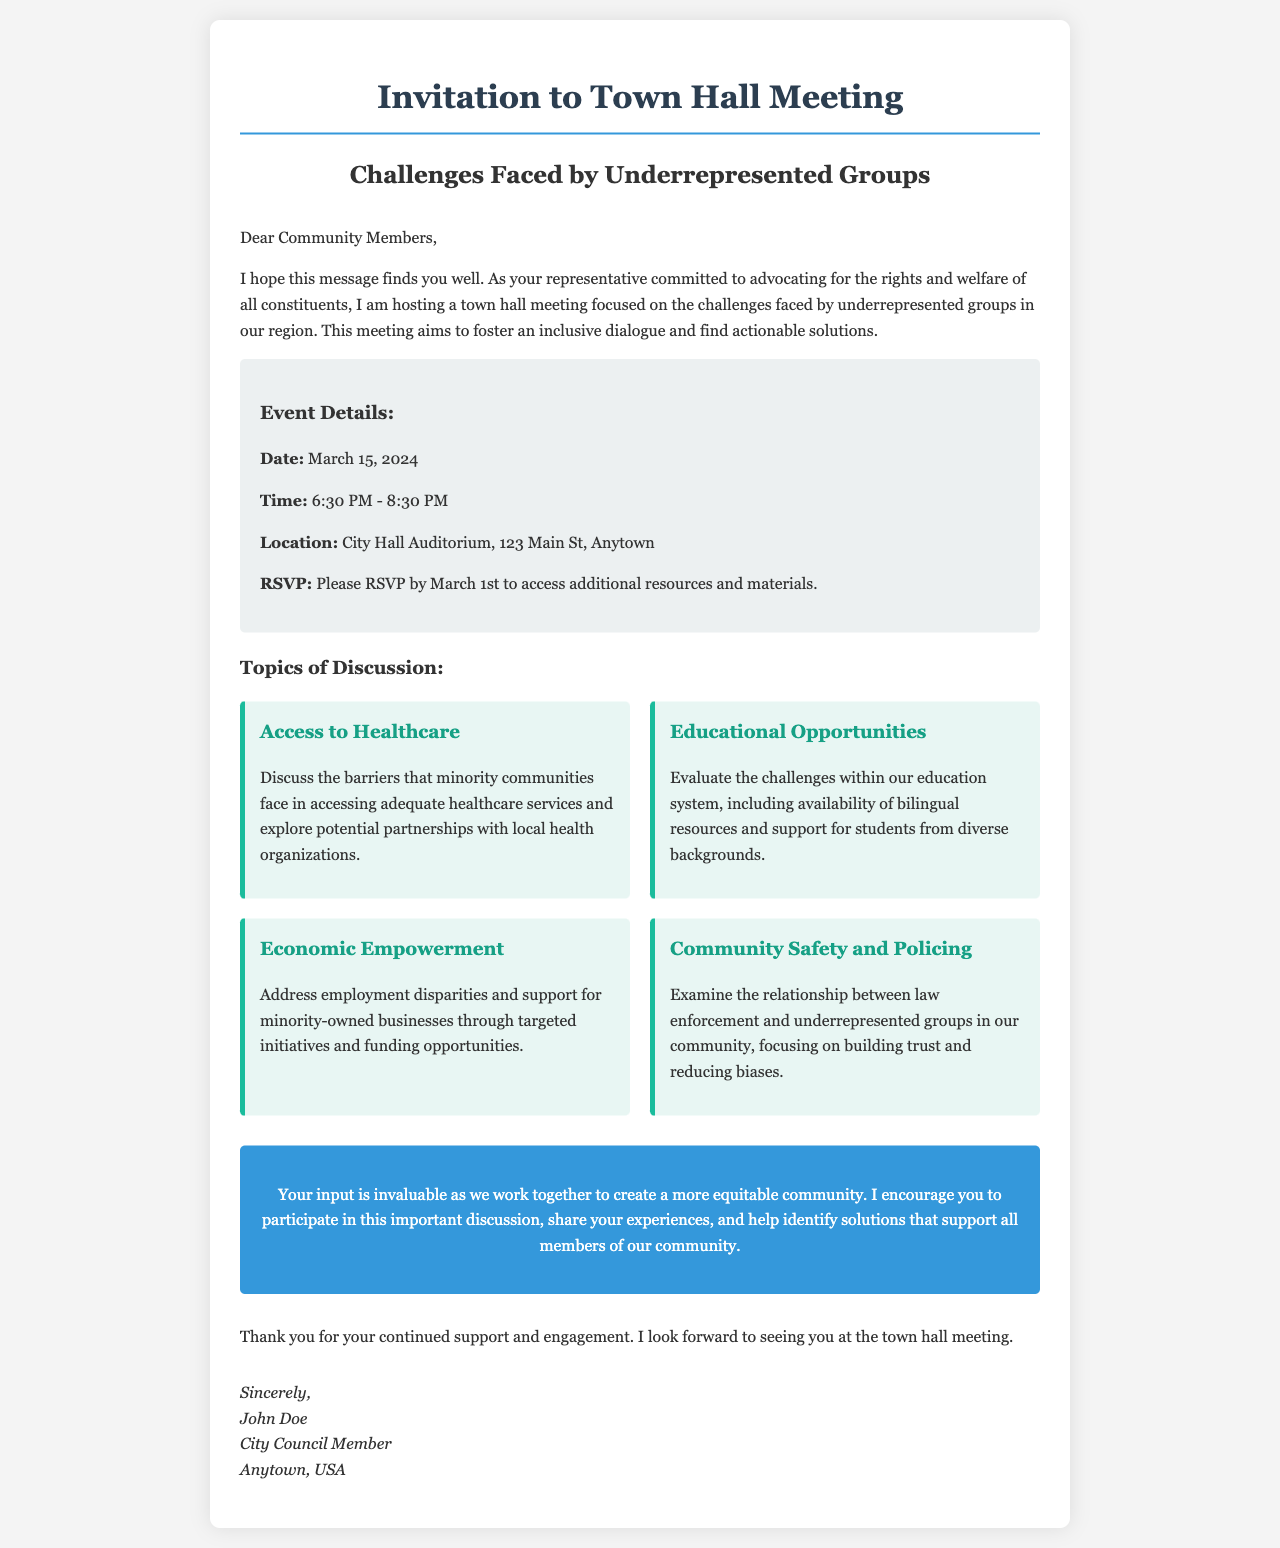What is the date of the town hall meeting? The date is explicitly stated in the event details section of the document.
Answer: March 15, 2024 What time will the town hall meeting take place? The time for the meeting is provided in the event details.
Answer: 6:30 PM - 8:30 PM Where will the meeting be held? The location is clearly mentioned in the event details section.
Answer: City Hall Auditorium, 123 Main St, Anytown What is one topic of discussion at the meeting? The document lists multiple topics to be discussed, highlighting their focus.
Answer: Access to Healthcare By what date should attendees RSVP? The RSVP deadline is given in the event details section.
Answer: March 1st Who is hosting the town hall meeting? The document names the host in the opening paragraph.
Answer: John Doe Why is this town hall meeting being held? The purpose of the meeting is described in the introduction.
Answer: To discuss challenges faced by underrepresented groups What is one goal of the meeting? The goals for the meeting can be inferred from its purpose as stated in the document.
Answer: Foster an inclusive dialogue 